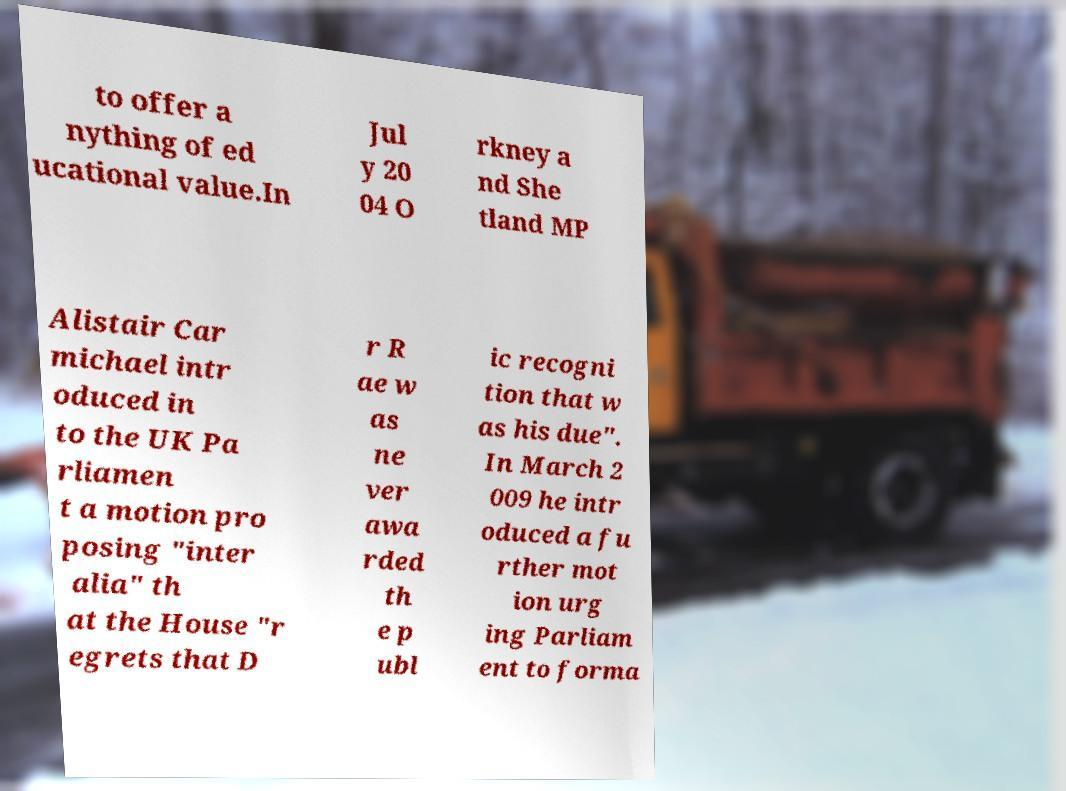For documentation purposes, I need the text within this image transcribed. Could you provide that? to offer a nything of ed ucational value.In Jul y 20 04 O rkney a nd She tland MP Alistair Car michael intr oduced in to the UK Pa rliamen t a motion pro posing "inter alia" th at the House "r egrets that D r R ae w as ne ver awa rded th e p ubl ic recogni tion that w as his due". In March 2 009 he intr oduced a fu rther mot ion urg ing Parliam ent to forma 